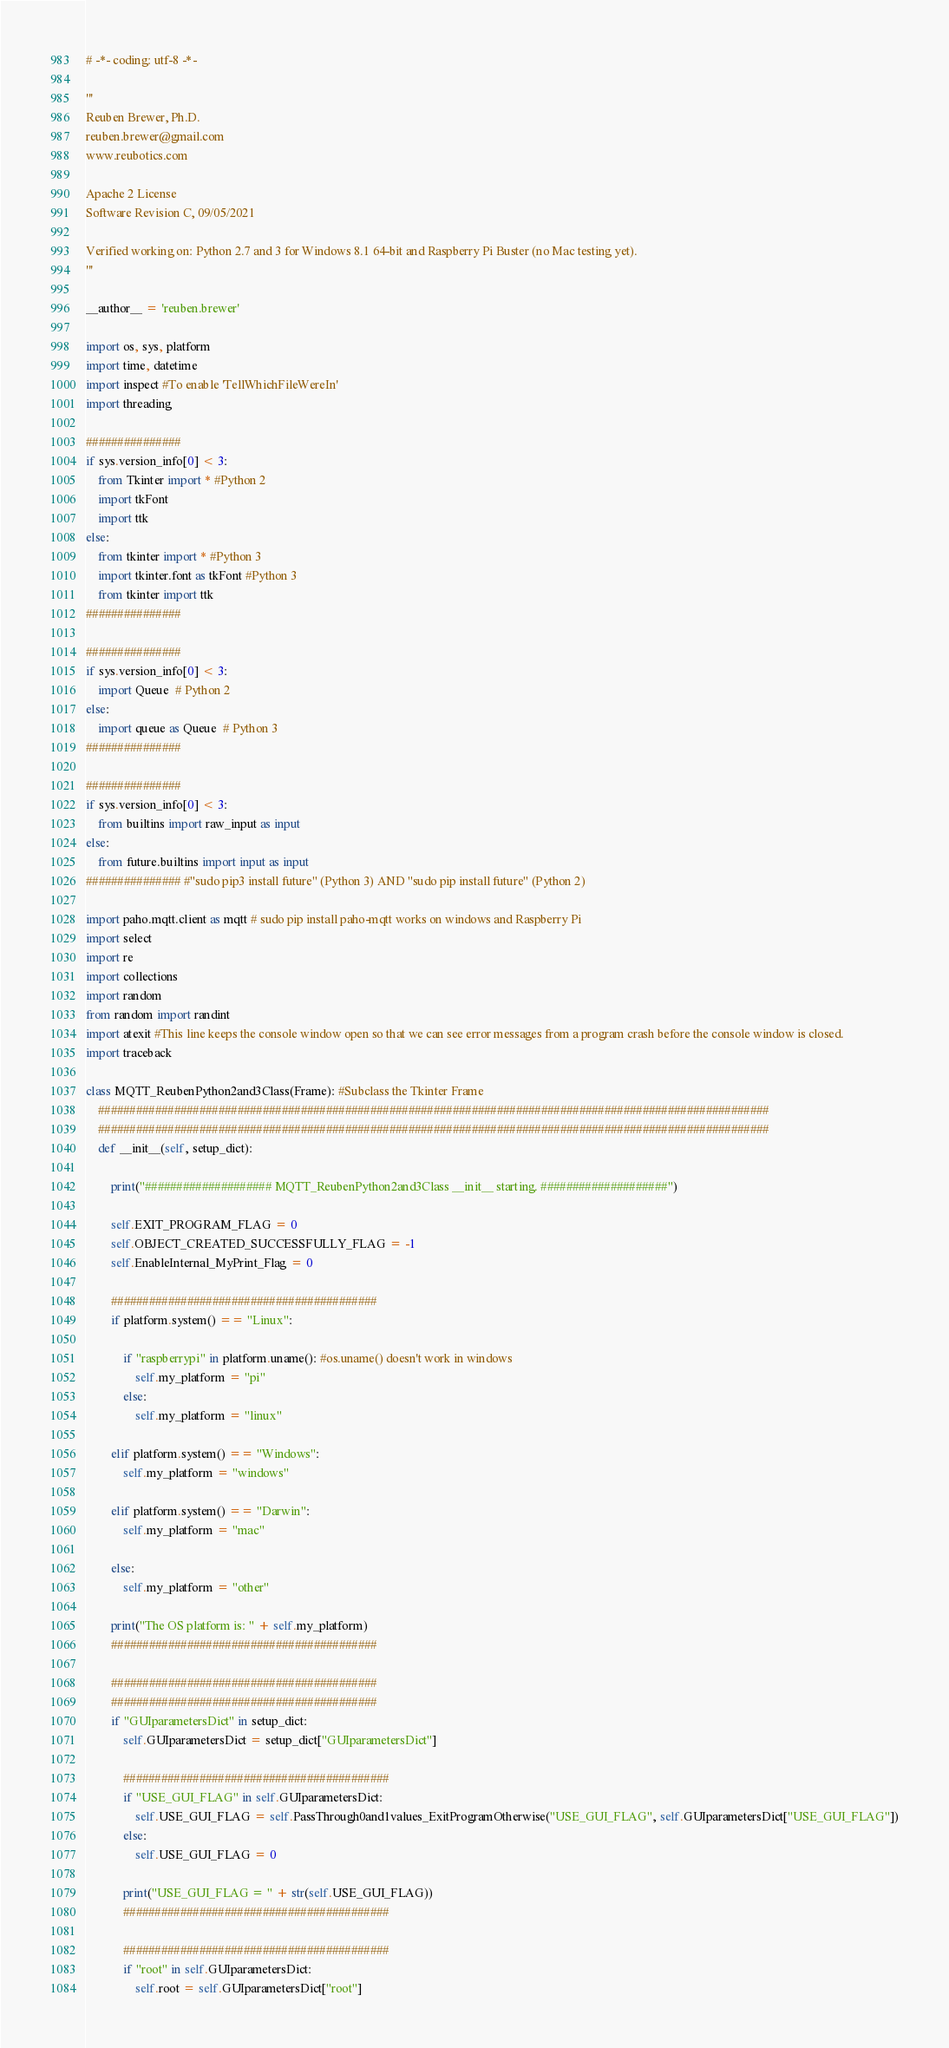<code> <loc_0><loc_0><loc_500><loc_500><_Python_># -*- coding: utf-8 -*-

'''
Reuben Brewer, Ph.D.
reuben.brewer@gmail.com
www.reubotics.com

Apache 2 License
Software Revision C, 09/05/2021

Verified working on: Python 2.7 and 3 for Windows 8.1 64-bit and Raspberry Pi Buster (no Mac testing yet).
'''

__author__ = 'reuben.brewer'

import os, sys, platform
import time, datetime
import inspect #To enable 'TellWhichFileWereIn'
import threading

###############
if sys.version_info[0] < 3:
    from Tkinter import * #Python 2
    import tkFont
    import ttk
else:
    from tkinter import * #Python 3
    import tkinter.font as tkFont #Python 3
    from tkinter import ttk
###############

###############
if sys.version_info[0] < 3:
    import Queue  # Python 2
else:
    import queue as Queue  # Python 3
###############

###############
if sys.version_info[0] < 3:
    from builtins import raw_input as input
else:
    from future.builtins import input as input
############### #"sudo pip3 install future" (Python 3) AND "sudo pip install future" (Python 2)

import paho.mqtt.client as mqtt # sudo pip install paho-mqtt works on windows and Raspberry Pi
import select
import re
import collections
import random
from random import randint
import atexit #This line keeps the console window open so that we can see error messages from a program crash before the console window is closed.
import traceback

class MQTT_ReubenPython2and3Class(Frame): #Subclass the Tkinter Frame
    ##########################################################################################################
    ##########################################################################################################
    def __init__(self, setup_dict):

        print("#################### MQTT_ReubenPython2and3Class __init__ starting. ####################")

        self.EXIT_PROGRAM_FLAG = 0
        self.OBJECT_CREATED_SUCCESSFULLY_FLAG = -1
        self.EnableInternal_MyPrint_Flag = 0

        ##########################################
        if platform.system() == "Linux":

            if "raspberrypi" in platform.uname(): #os.uname() doesn't work in windows
                self.my_platform = "pi"
            else:
                self.my_platform = "linux"

        elif platform.system() == "Windows":
            self.my_platform = "windows"

        elif platform.system() == "Darwin":
            self.my_platform = "mac"

        else:
            self.my_platform = "other"

        print("The OS platform is: " + self.my_platform)
        ##########################################

        ##########################################
        ##########################################
        if "GUIparametersDict" in setup_dict:
            self.GUIparametersDict = setup_dict["GUIparametersDict"]

            ##########################################
            if "USE_GUI_FLAG" in self.GUIparametersDict:
                self.USE_GUI_FLAG = self.PassThrough0and1values_ExitProgramOtherwise("USE_GUI_FLAG", self.GUIparametersDict["USE_GUI_FLAG"])
            else:
                self.USE_GUI_FLAG = 0

            print("USE_GUI_FLAG = " + str(self.USE_GUI_FLAG))
            ##########################################

            ##########################################
            if "root" in self.GUIparametersDict:
                self.root = self.GUIparametersDict["root"]</code> 